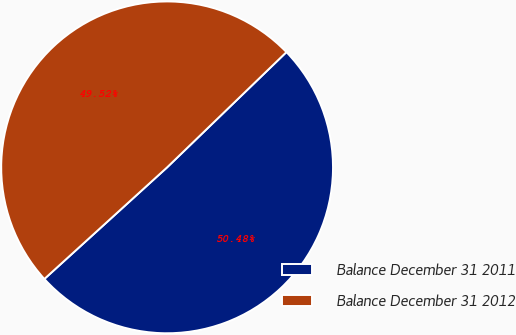Convert chart. <chart><loc_0><loc_0><loc_500><loc_500><pie_chart><fcel>Balance December 31 2011<fcel>Balance December 31 2012<nl><fcel>50.48%<fcel>49.52%<nl></chart> 